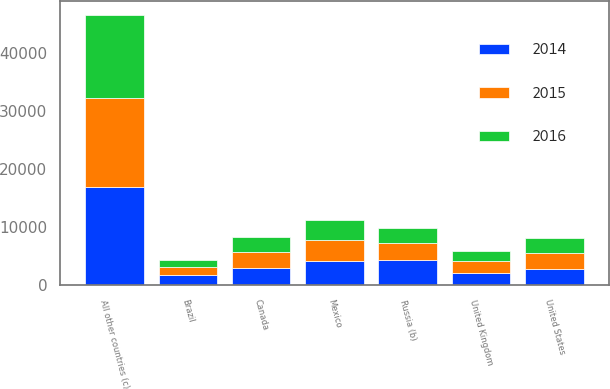Convert chart to OTSL. <chart><loc_0><loc_0><loc_500><loc_500><stacked_bar_chart><ecel><fcel>United States<fcel>Mexico<fcel>Canada<fcel>Russia (b)<fcel>United Kingdom<fcel>Brazil<fcel>All other countries (c)<nl><fcel>2016<fcel>2744.5<fcel>3431<fcel>2692<fcel>2648<fcel>1737<fcel>1305<fcel>14254<nl><fcel>2015<fcel>2744.5<fcel>3687<fcel>2677<fcel>2797<fcel>1966<fcel>1289<fcel>15374<nl><fcel>2014<fcel>2744.5<fcel>4113<fcel>3022<fcel>4414<fcel>2174<fcel>1790<fcel>16951<nl></chart> 